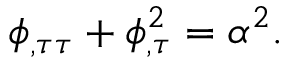Convert formula to latex. <formula><loc_0><loc_0><loc_500><loc_500>\phi _ { , \tau \tau } + \phi _ { , \tau } ^ { 2 } = \alpha ^ { 2 } .</formula> 